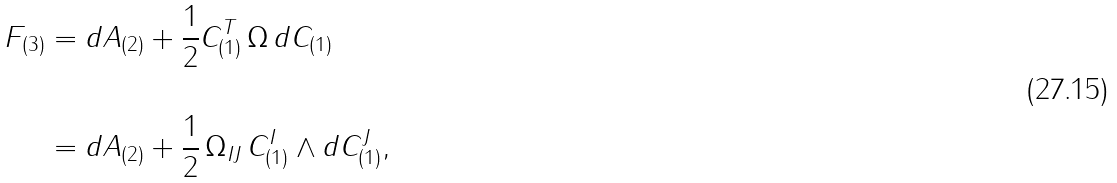<formula> <loc_0><loc_0><loc_500><loc_500>F _ { ( 3 ) } & = d A _ { ( 2 ) } + \frac { 1 } { 2 } C _ { ( 1 ) } ^ { T } \, \Omega \, d C _ { ( 1 ) } \\ \\ & = d A _ { ( 2 ) } + \frac { 1 } { 2 } \, \Omega _ { I J } \, C _ { ( 1 ) } ^ { I } \wedge d C _ { ( 1 ) } ^ { J } ,</formula> 